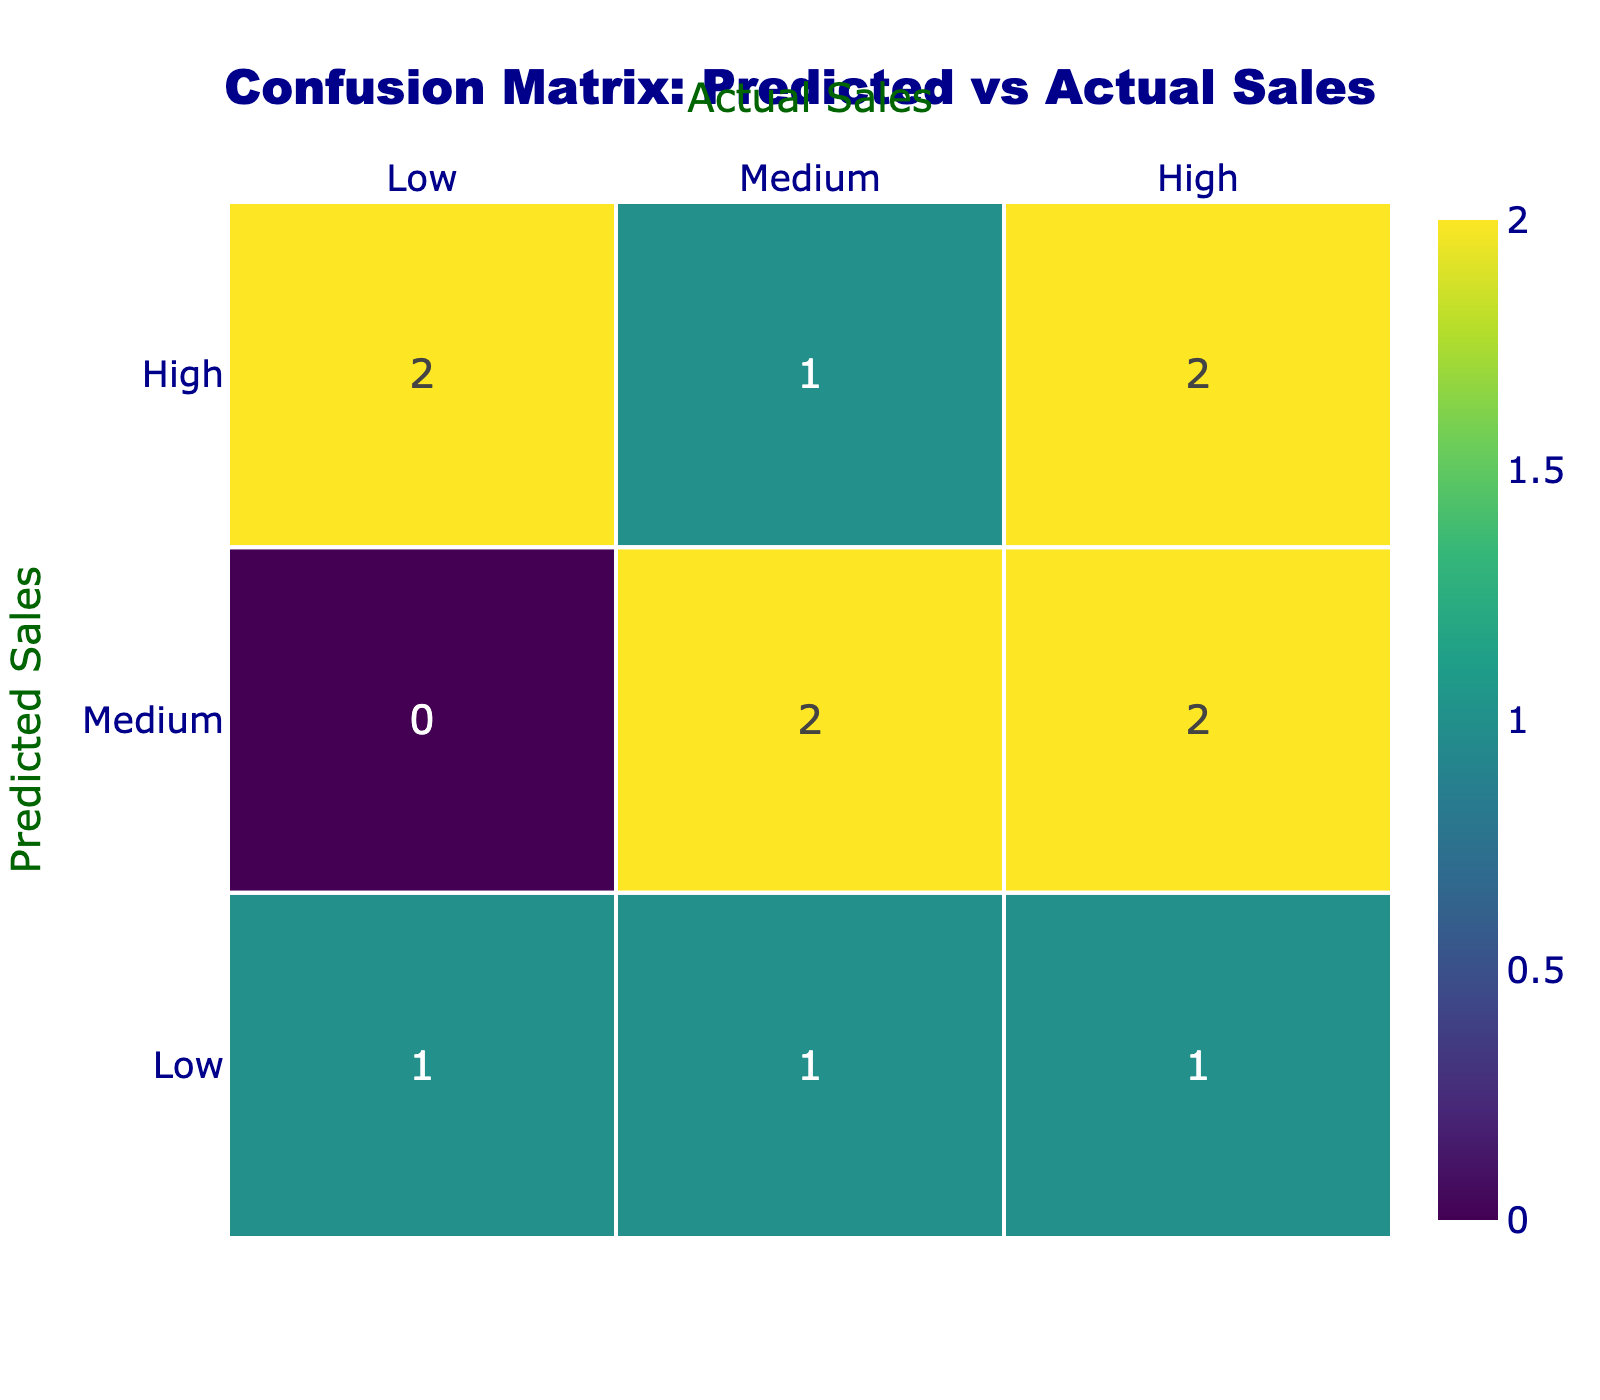Which marketing strategy had the highest predicted sales? In the table, "Social Media Campaign," "Influencer Partnership," and "Historical Society Membership Drive" all had a predicted sales outcome of "High." Since the question asks for the highest predicted sales, any of these strategies can be considered correct.
Answer: Social Media Campaign, Influencer Partnership, Historical Society Membership Drive What is the actual sales outcome for the "Email Newsletter" marketing strategy? According to the table, the "Email Newsletter" had a predicted sales of "High" but an actual sales outcome of "Low." This can be found by looking specifically at the row corresponding to the "Email Newsletter."
Answer: Low How many marketing strategies predicted medium sales? The strategies that predicted medium sales are "Book Fair Promotion," "Print Advertising," "Academic Journal Feature," and "Online Webinar," making the total count of strategies that predicted medium sales four.
Answer: 4 Is it true that all marketing strategies that predicted high sales had actual high sales outcomes? This can be evaluated by checking the strategies predicted as high sales, which are "Social Media Campaign," "Influencer Partnership," and "Historical Society Membership Drive." Out of these, "Social Media Campaign" and "Historical Society Membership Drive" had actual high sales, while "Influencer Partnership" had low sales. Therefore, it is not true that all had actual high sales outcomes.
Answer: No What is the difference between the number of strategies that had actual high sales and those that had actual low sales? The strategies with actual high sales are "Social Media Campaign," "Local History Podcast," "Library Book Signing," and "Historical Society Membership Drive," totaling four. The strategies with actual low sales are "Email Newsletter," "University Collaboration," and "Influencer Partnership," totaling three. The difference is 4 - 3 = 1.
Answer: 1 How many strategies predicted low sales, and what was the actual outcome of the "Community Event Sponsorship"? The strategies that predicted low sales are "University Collaboration" and "Community Event Sponsorship," totaling two. Looking at the actual sales outcome for "Community Event Sponsorship," it shows "High."
Answer: 2, High Which predicted sales outcome had more actual sales responses, medium or high? For actual medium sales, the "Book Fair Promotion," "Print Advertising," and "Academic Journal Feature" count as three responses. For actual high sales, counting "Social Media Campaign," "Local History Podcast," "Library Book Signing," and "Historical Society Membership Drive" gives us four responses. Since four is more than three, high sales responses are greater than medium.
Answer: High What is the total count of marketing strategies with predicted low sales? The strategies that predicted low sales are "University Collaboration" and "Community Event Sponsorship," making the total count two.
Answer: 2 